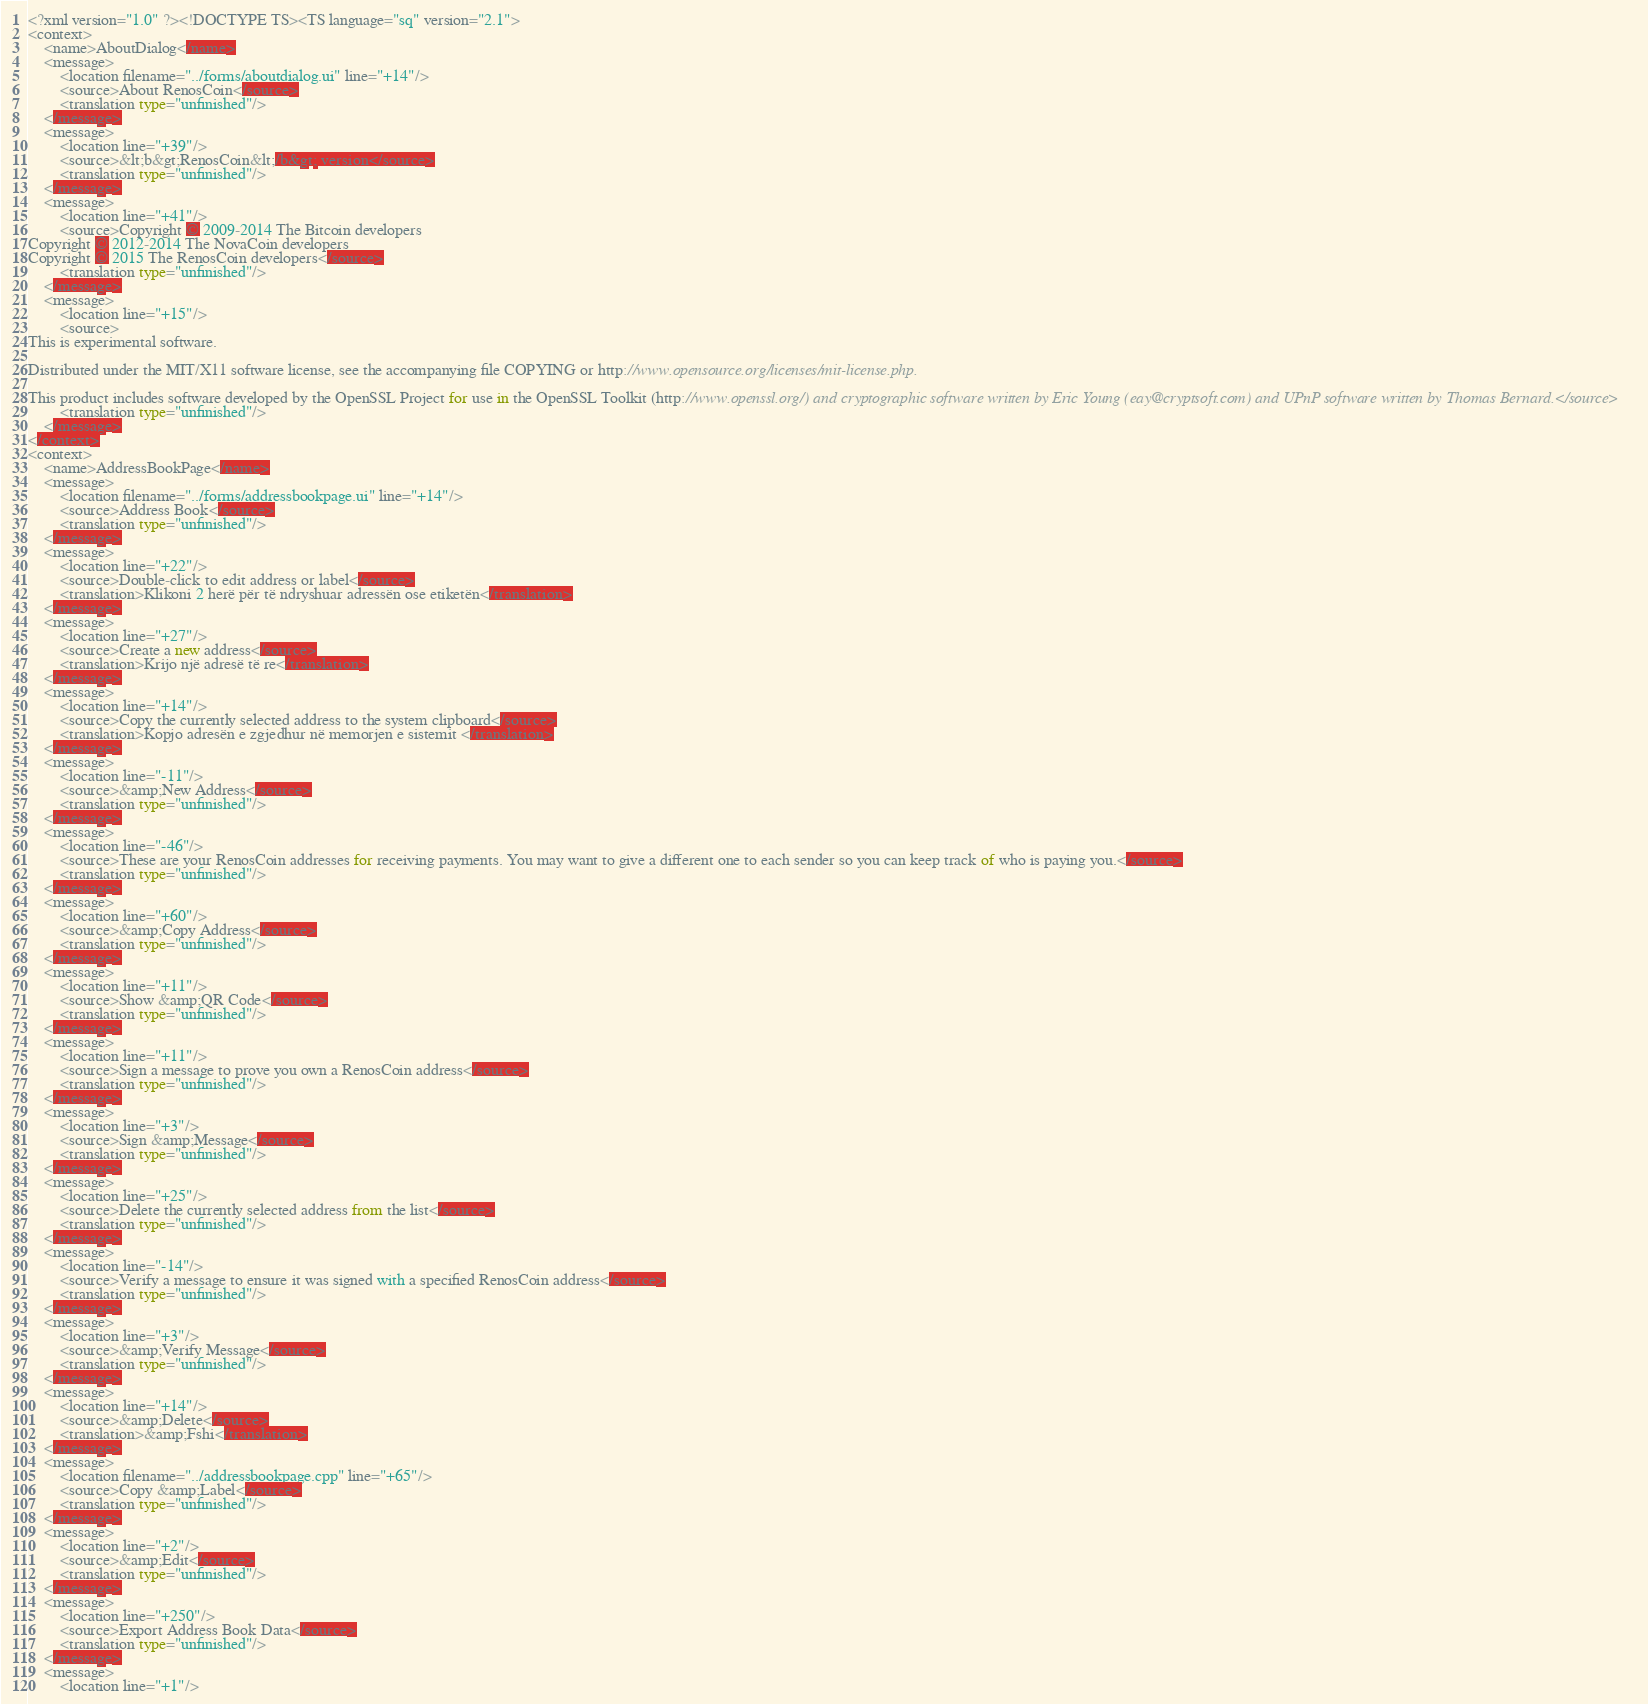Convert code to text. <code><loc_0><loc_0><loc_500><loc_500><_TypeScript_><?xml version="1.0" ?><!DOCTYPE TS><TS language="sq" version="2.1">
<context>
    <name>AboutDialog</name>
    <message>
        <location filename="../forms/aboutdialog.ui" line="+14"/>
        <source>About RenosCoin</source>
        <translation type="unfinished"/>
    </message>
    <message>
        <location line="+39"/>
        <source>&lt;b&gt;RenosCoin&lt;/b&gt; version</source>
        <translation type="unfinished"/>
    </message>
    <message>
        <location line="+41"/>
        <source>Copyright © 2009-2014 The Bitcoin developers
Copyright © 2012-2014 The NovaCoin developers
Copyright © 2015 The RenosCoin developers</source>
        <translation type="unfinished"/>
    </message>
    <message>
        <location line="+15"/>
        <source>
This is experimental software.

Distributed under the MIT/X11 software license, see the accompanying file COPYING or http://www.opensource.org/licenses/mit-license.php.

This product includes software developed by the OpenSSL Project for use in the OpenSSL Toolkit (http://www.openssl.org/) and cryptographic software written by Eric Young (eay@cryptsoft.com) and UPnP software written by Thomas Bernard.</source>
        <translation type="unfinished"/>
    </message>
</context>
<context>
    <name>AddressBookPage</name>
    <message>
        <location filename="../forms/addressbookpage.ui" line="+14"/>
        <source>Address Book</source>
        <translation type="unfinished"/>
    </message>
    <message>
        <location line="+22"/>
        <source>Double-click to edit address or label</source>
        <translation>Klikoni 2 herë për të ndryshuar adressën ose etiketën</translation>
    </message>
    <message>
        <location line="+27"/>
        <source>Create a new address</source>
        <translation>Krijo një adresë të re</translation>
    </message>
    <message>
        <location line="+14"/>
        <source>Copy the currently selected address to the system clipboard</source>
        <translation>Kopjo adresën e zgjedhur në memorjen e sistemit </translation>
    </message>
    <message>
        <location line="-11"/>
        <source>&amp;New Address</source>
        <translation type="unfinished"/>
    </message>
    <message>
        <location line="-46"/>
        <source>These are your RenosCoin addresses for receiving payments. You may want to give a different one to each sender so you can keep track of who is paying you.</source>
        <translation type="unfinished"/>
    </message>
    <message>
        <location line="+60"/>
        <source>&amp;Copy Address</source>
        <translation type="unfinished"/>
    </message>
    <message>
        <location line="+11"/>
        <source>Show &amp;QR Code</source>
        <translation type="unfinished"/>
    </message>
    <message>
        <location line="+11"/>
        <source>Sign a message to prove you own a RenosCoin address</source>
        <translation type="unfinished"/>
    </message>
    <message>
        <location line="+3"/>
        <source>Sign &amp;Message</source>
        <translation type="unfinished"/>
    </message>
    <message>
        <location line="+25"/>
        <source>Delete the currently selected address from the list</source>
        <translation type="unfinished"/>
    </message>
    <message>
        <location line="-14"/>
        <source>Verify a message to ensure it was signed with a specified RenosCoin address</source>
        <translation type="unfinished"/>
    </message>
    <message>
        <location line="+3"/>
        <source>&amp;Verify Message</source>
        <translation type="unfinished"/>
    </message>
    <message>
        <location line="+14"/>
        <source>&amp;Delete</source>
        <translation>&amp;Fshi</translation>
    </message>
    <message>
        <location filename="../addressbookpage.cpp" line="+65"/>
        <source>Copy &amp;Label</source>
        <translation type="unfinished"/>
    </message>
    <message>
        <location line="+2"/>
        <source>&amp;Edit</source>
        <translation type="unfinished"/>
    </message>
    <message>
        <location line="+250"/>
        <source>Export Address Book Data</source>
        <translation type="unfinished"/>
    </message>
    <message>
        <location line="+1"/></code> 